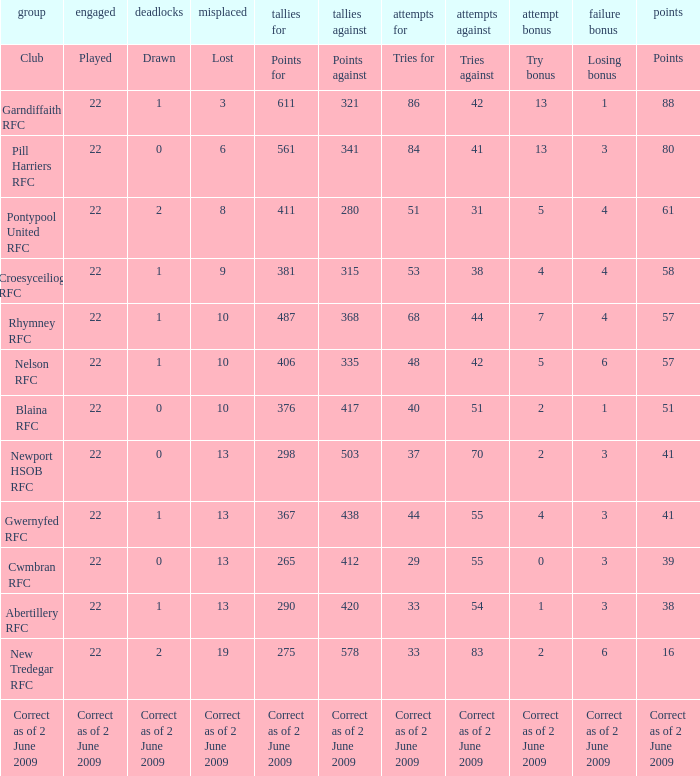How many points against did the club with a losing bonus of 3 and 84 tries have? 341.0. 